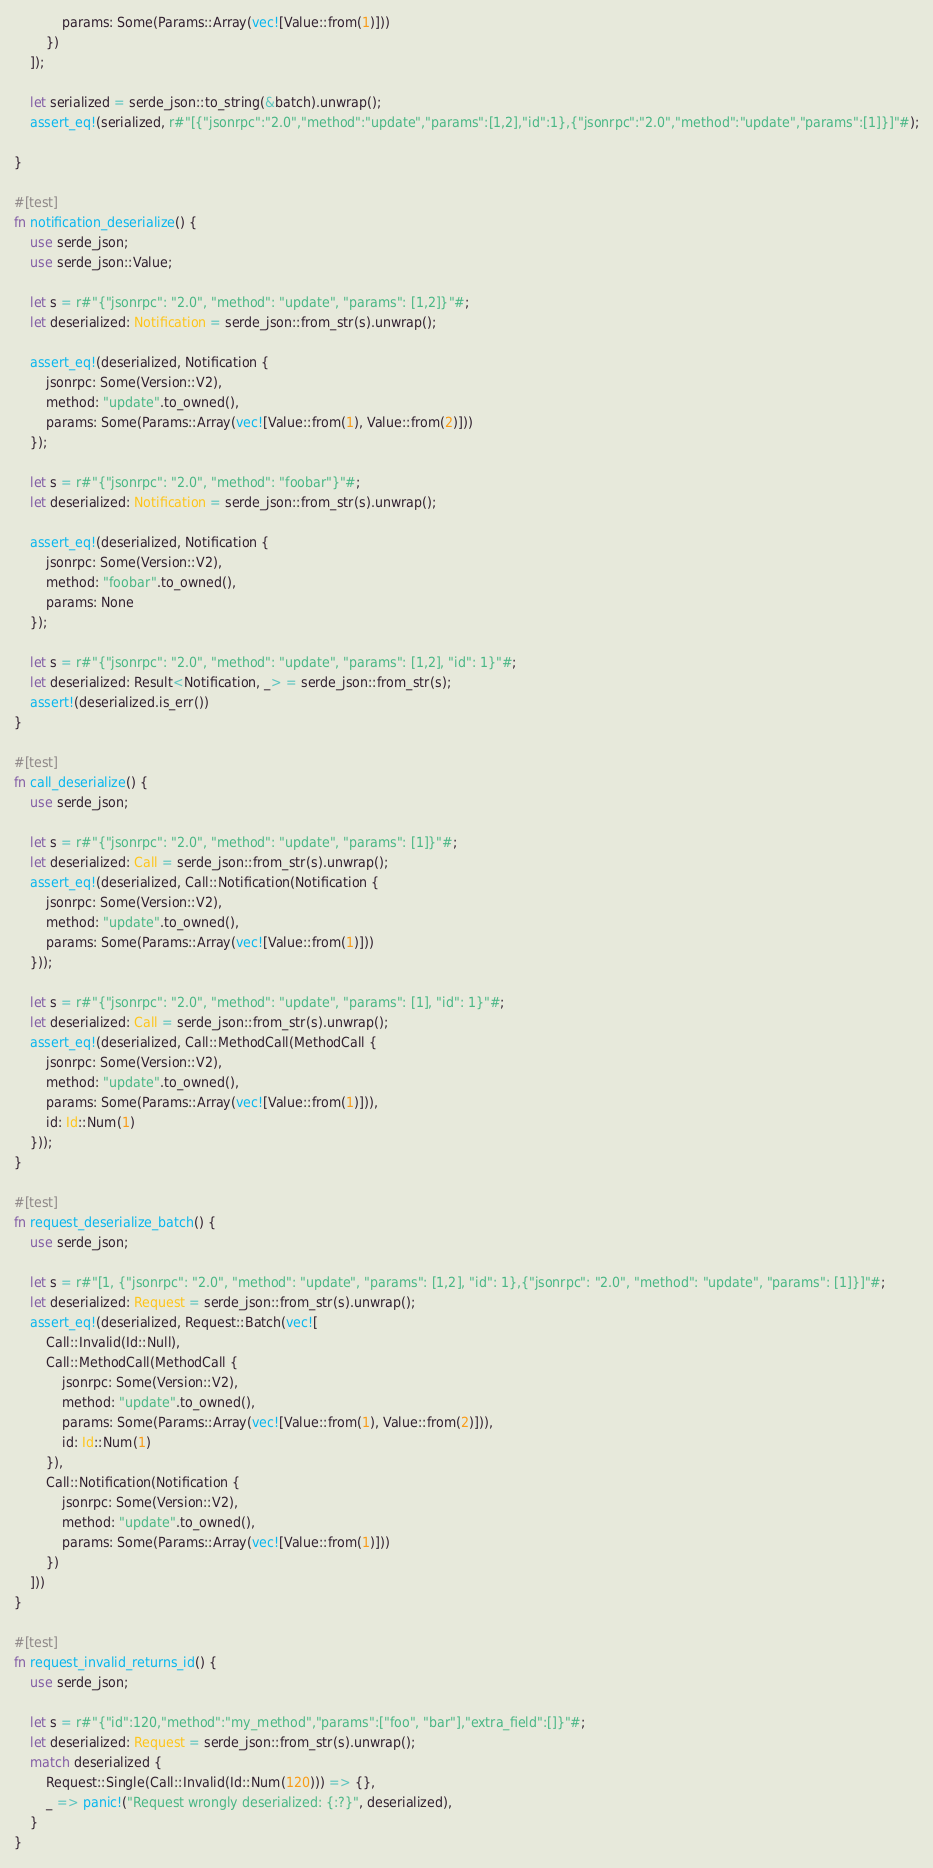Convert code to text. <code><loc_0><loc_0><loc_500><loc_500><_Rust_>			params: Some(Params::Array(vec![Value::from(1)]))
		})
	]);

	let serialized = serde_json::to_string(&batch).unwrap();
	assert_eq!(serialized, r#"[{"jsonrpc":"2.0","method":"update","params":[1,2],"id":1},{"jsonrpc":"2.0","method":"update","params":[1]}]"#);

}

#[test]
fn notification_deserialize() {
	use serde_json;
	use serde_json::Value;

	let s = r#"{"jsonrpc": "2.0", "method": "update", "params": [1,2]}"#;
	let deserialized: Notification = serde_json::from_str(s).unwrap();

	assert_eq!(deserialized, Notification {
		jsonrpc: Some(Version::V2),
		method: "update".to_owned(),
		params: Some(Params::Array(vec![Value::from(1), Value::from(2)]))
	});

	let s = r#"{"jsonrpc": "2.0", "method": "foobar"}"#;
	let deserialized: Notification = serde_json::from_str(s).unwrap();

	assert_eq!(deserialized, Notification {
		jsonrpc: Some(Version::V2),
		method: "foobar".to_owned(),
		params: None
	});

	let s = r#"{"jsonrpc": "2.0", "method": "update", "params": [1,2], "id": 1}"#;
	let deserialized: Result<Notification, _> = serde_json::from_str(s);
	assert!(deserialized.is_err())
}

#[test]
fn call_deserialize() {
	use serde_json;

	let s = r#"{"jsonrpc": "2.0", "method": "update", "params": [1]}"#;
	let deserialized: Call = serde_json::from_str(s).unwrap();
	assert_eq!(deserialized, Call::Notification(Notification {
		jsonrpc: Some(Version::V2),
		method: "update".to_owned(),
		params: Some(Params::Array(vec![Value::from(1)]))
	}));

	let s = r#"{"jsonrpc": "2.0", "method": "update", "params": [1], "id": 1}"#;
	let deserialized: Call = serde_json::from_str(s).unwrap();
	assert_eq!(deserialized, Call::MethodCall(MethodCall {
		jsonrpc: Some(Version::V2),
		method: "update".to_owned(),
		params: Some(Params::Array(vec![Value::from(1)])),
		id: Id::Num(1)
	}));
}

#[test]
fn request_deserialize_batch() {
	use serde_json;

	let s = r#"[1, {"jsonrpc": "2.0", "method": "update", "params": [1,2], "id": 1},{"jsonrpc": "2.0", "method": "update", "params": [1]}]"#;
	let deserialized: Request = serde_json::from_str(s).unwrap();
	assert_eq!(deserialized, Request::Batch(vec![
		Call::Invalid(Id::Null),
		Call::MethodCall(MethodCall {
			jsonrpc: Some(Version::V2),
			method: "update".to_owned(),
			params: Some(Params::Array(vec![Value::from(1), Value::from(2)])),
			id: Id::Num(1)
		}),
		Call::Notification(Notification {
			jsonrpc: Some(Version::V2),
			method: "update".to_owned(),
			params: Some(Params::Array(vec![Value::from(1)]))
		})
	]))
}

#[test]
fn request_invalid_returns_id() {
	use serde_json;

	let s = r#"{"id":120,"method":"my_method","params":["foo", "bar"],"extra_field":[]}"#;
	let deserialized: Request = serde_json::from_str(s).unwrap();
	match deserialized {
		Request::Single(Call::Invalid(Id::Num(120))) => {},
		_ => panic!("Request wrongly deserialized: {:?}", deserialized),
	}
}
</code> 